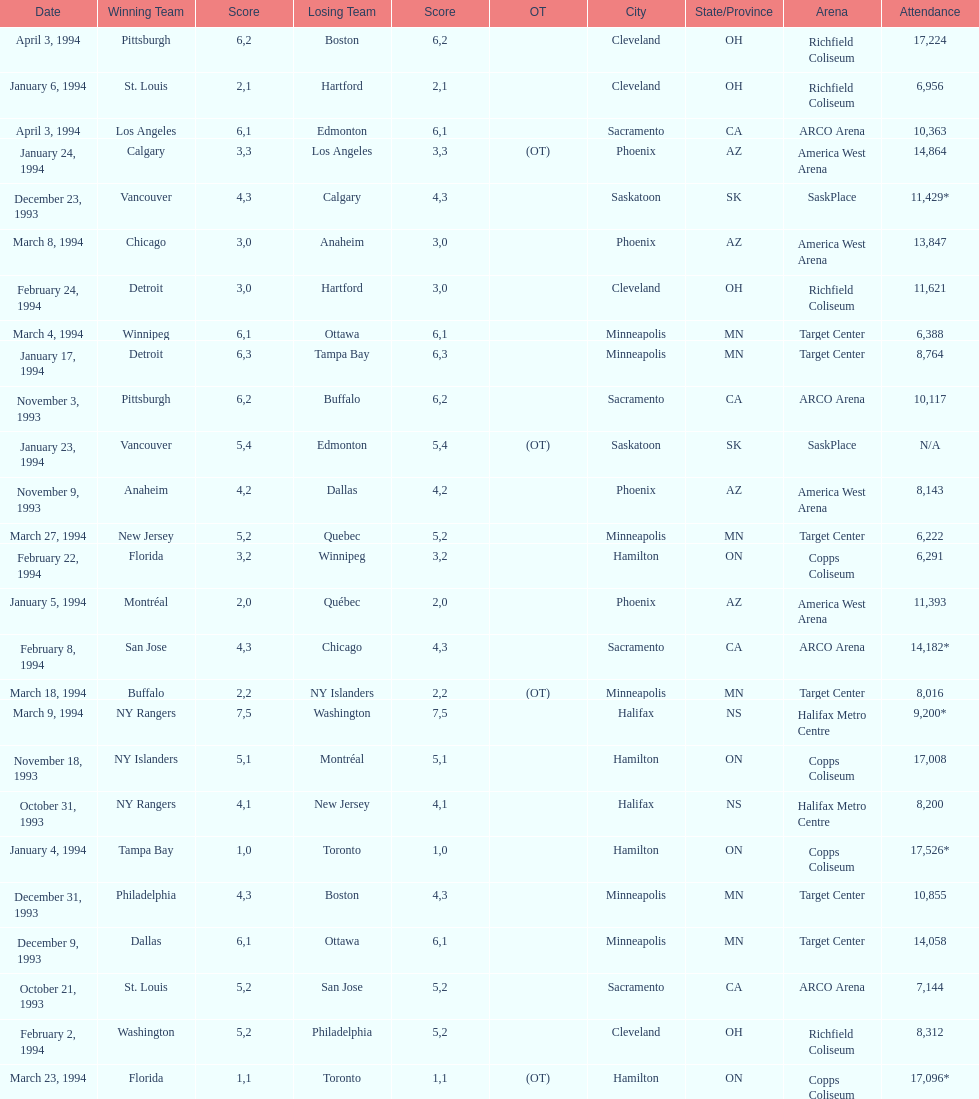How many events occurred in minneapolis, mn? 6. 